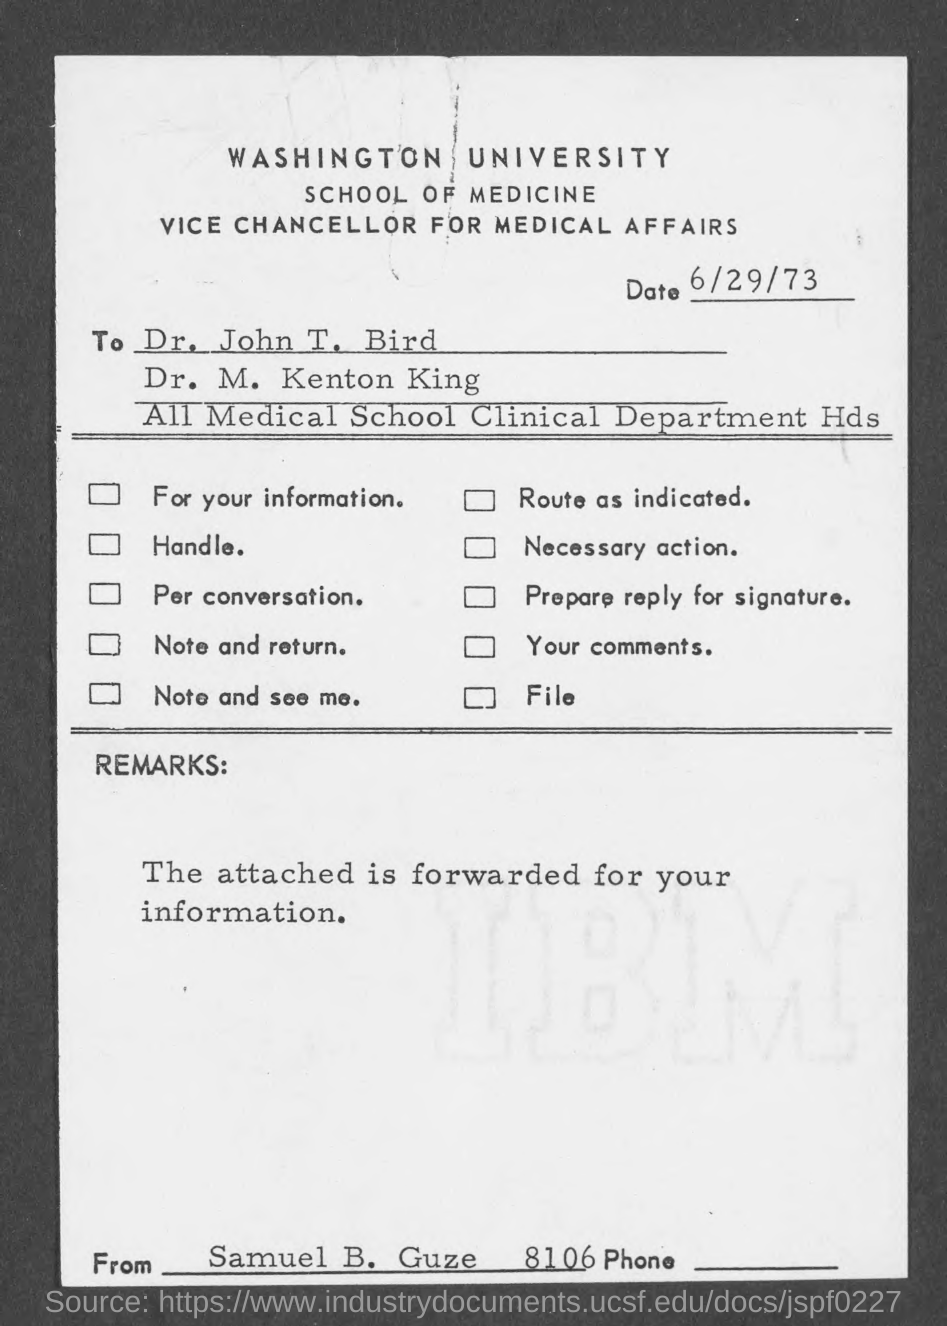List a handful of essential elements in this visual. Samuel B. Guze wrote the letter. The date is June 29th, 1973. 